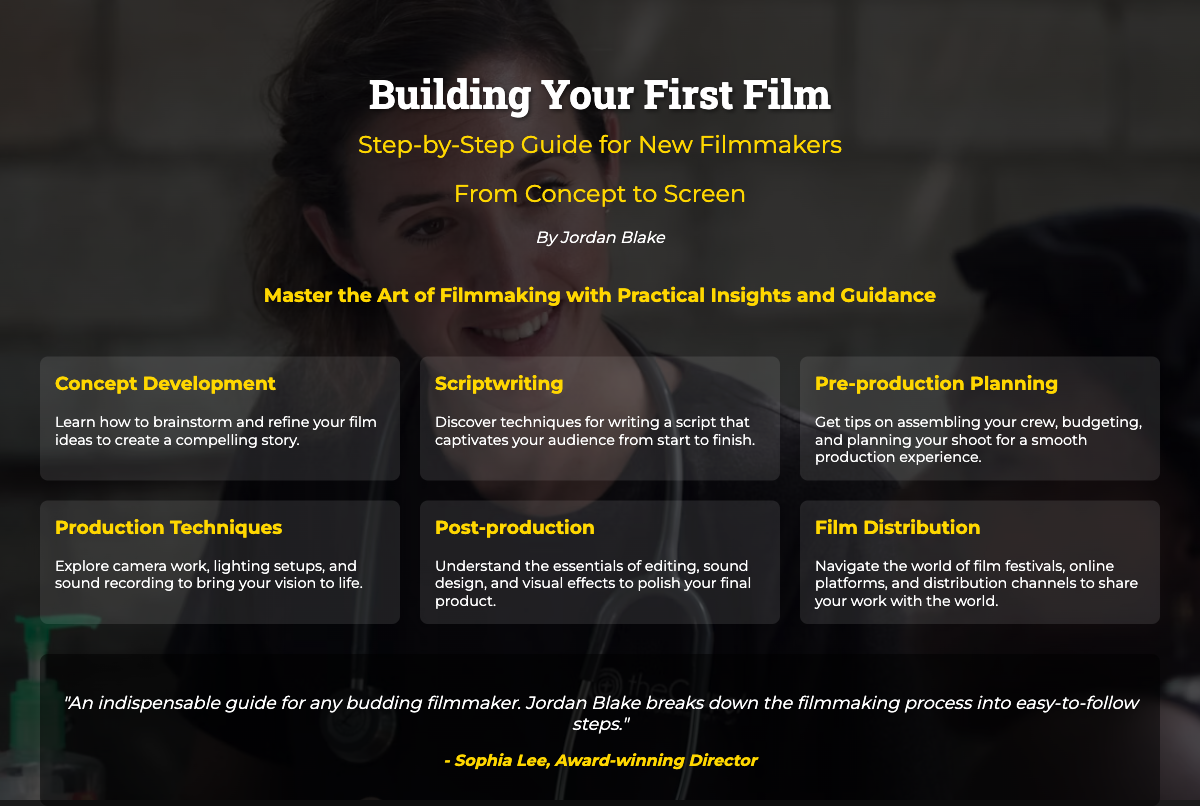What is the title of the book? The title is prominently displayed at the top of the document, making it the first piece of information a viewer sees.
Answer: Building Your First Film Who is the author of the book? The author's name is listed below the title and subtitle, providing clear attribution for the work.
Answer: Jordan Blake What is the main theme of the book? The tagline summarizes the book's core focus, highlighting its intention in the filmmaking process.
Answer: Master the Art of Filmmaking How many highlights are listed on the cover? The highlights section consists of a series of six distinct topics related to filmmaking, making it easy to count.
Answer: Six Which highlight covers the aspect of writing? The highlights are categorized by key filmmaking processes, with one specifically addressing script writing.
Answer: Scriptwriting What is the profession of the person providing the endorsement? The title before the person's name indicates their recognition and background in the film industry.
Answer: Award-winning Director What is the subtitle of the book? The subtitle follows the title and gives further context about the book's purpose for new filmmakers.
Answer: Step-by-Step Guide for New Filmmakers In what section can you find "Pre-production Planning"? The section where "Pre-production Planning" is located is part of the highlights, indicating key filmmaking areas.
Answer: Highlights What is the color of the tagline? The color used for the tagline is distinctively styled to stand out against the background.
Answer: #ffd700 